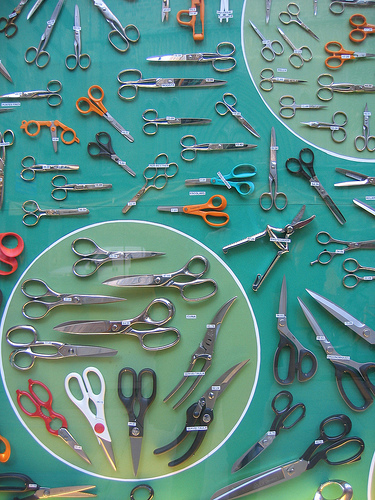Which color are the large scissors, black or red? The large scissors in the photo are black in color. 